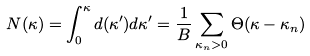<formula> <loc_0><loc_0><loc_500><loc_500>N ( \kappa ) = \int _ { 0 } ^ { \kappa } d ( \kappa ^ { \prime } ) d \kappa ^ { \prime } = \frac { 1 } { B } \sum _ { \kappa _ { n } > 0 } \Theta ( \kappa - \kappa _ { n } )</formula> 